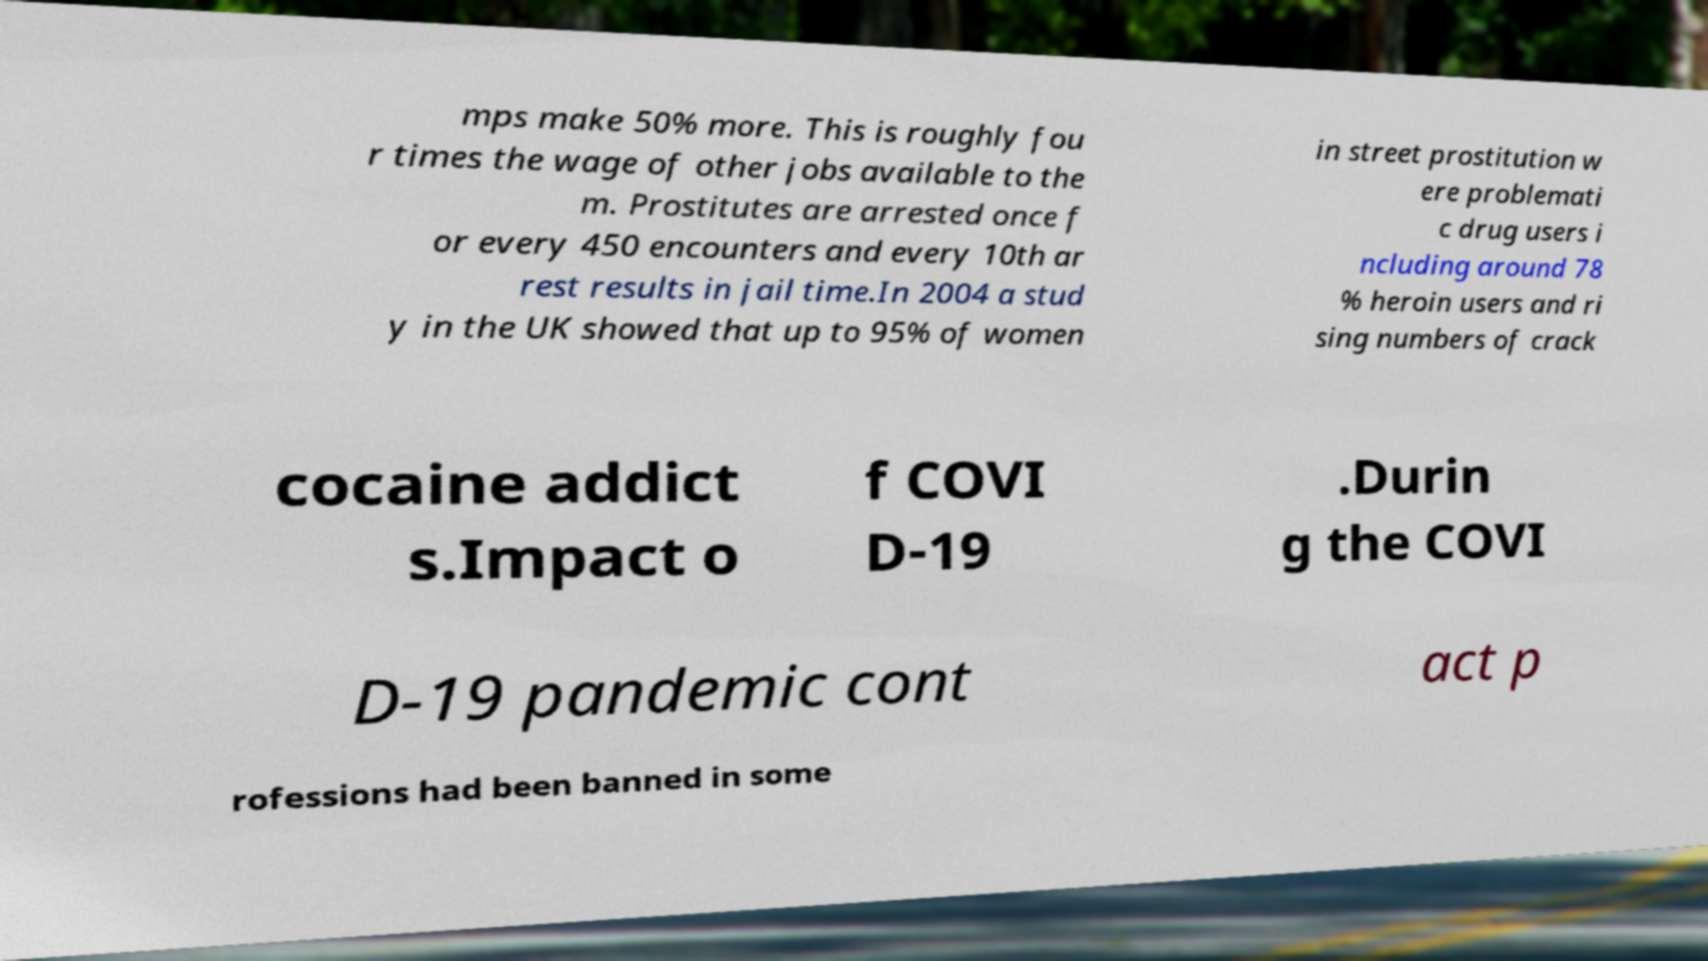Can you read and provide the text displayed in the image?This photo seems to have some interesting text. Can you extract and type it out for me? mps make 50% more. This is roughly fou r times the wage of other jobs available to the m. Prostitutes are arrested once f or every 450 encounters and every 10th ar rest results in jail time.In 2004 a stud y in the UK showed that up to 95% of women in street prostitution w ere problemati c drug users i ncluding around 78 % heroin users and ri sing numbers of crack cocaine addict s.Impact o f COVI D-19 .Durin g the COVI D-19 pandemic cont act p rofessions had been banned in some 